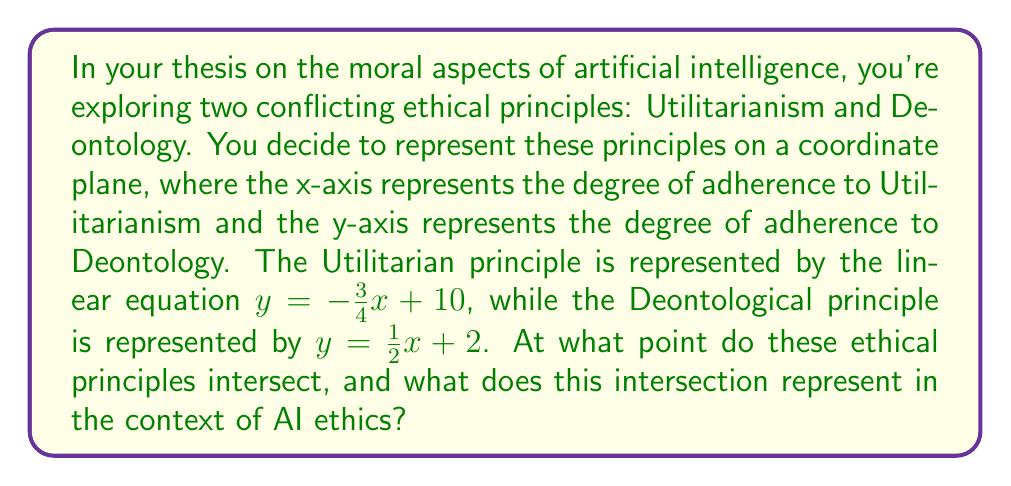Can you solve this math problem? To find the intersection point of these two ethical principles, we need to solve the system of linear equations:

$$\begin{cases}
y = -\frac{3}{4}x + 10 \quad \text{(Utilitarianism)}\\
y = \frac{1}{2}x + 2 \quad \text{(Deontology)}
\end{cases}$$

At the intersection point, the y-values are equal, so we can set the right sides of the equations equal to each other:

$$-\frac{3}{4}x + 10 = \frac{1}{2}x + 2$$

Now, let's solve for x:

1) First, add $\frac{3}{4}x$ to both sides:
   $$10 = \frac{5}{4}x + 2$$

2) Subtract 2 from both sides:
   $$8 = \frac{5}{4}x$$

3) Multiply both sides by $\frac{4}{5}$:
   $$\frac{32}{5} = x$$

Now that we have x, we can substitute this value into either of the original equations to find y. Let's use the Utilitarianism equation:

$$\begin{align}
y &= -\frac{3}{4}(\frac{32}{5}) + 10 \\
&= -\frac{24}{5} + 10 \\
&= -\frac{24}{5} + \frac{50}{5} \\
&= \frac{26}{5}
\end{align}$$

Therefore, the intersection point is $(\frac{32}{5}, \frac{26}{5})$ or $(6.4, 5.2)$.

In the context of AI ethics, this intersection point represents a balance between Utilitarian and Deontological principles. At this point, an AI system would be adhering equally to both ethical frameworks, potentially suggesting a compromised approach that considers both the consequences of actions (Utilitarianism) and the inherent rightness or wrongness of actions (Deontology).
Answer: The ethical principles intersect at the point $(\frac{32}{5}, \frac{26}{5})$ or approximately $(6.4, 5.2)$. 